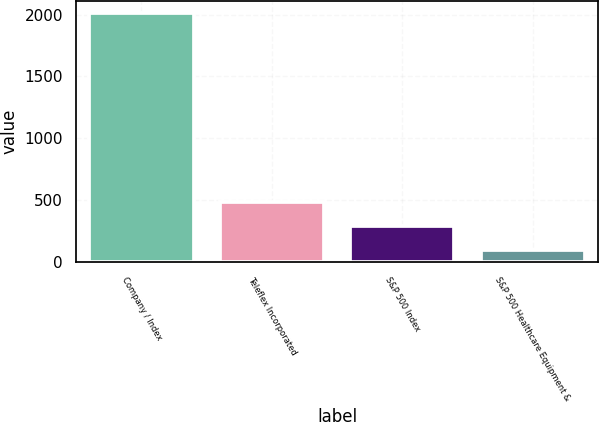<chart> <loc_0><loc_0><loc_500><loc_500><bar_chart><fcel>Company / Index<fcel>Teleflex Incorporated<fcel>S&P 500 Index<fcel>S&P 500 Healthcare Equipment &<nl><fcel>2011<fcel>481.4<fcel>290.2<fcel>99<nl></chart> 